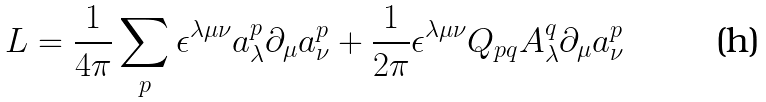Convert formula to latex. <formula><loc_0><loc_0><loc_500><loc_500>L = \frac { 1 } { 4 \pi } \sum _ { p } \epsilon ^ { \lambda \mu \nu } a ^ { p } _ { \lambda } \partial _ { \mu } a ^ { p } _ { \nu } + \frac { 1 } { 2 \pi } \epsilon ^ { \lambda \mu \nu } Q _ { p q } A ^ { q } _ { \lambda } \partial _ { \mu } a ^ { p } _ { \nu }</formula> 